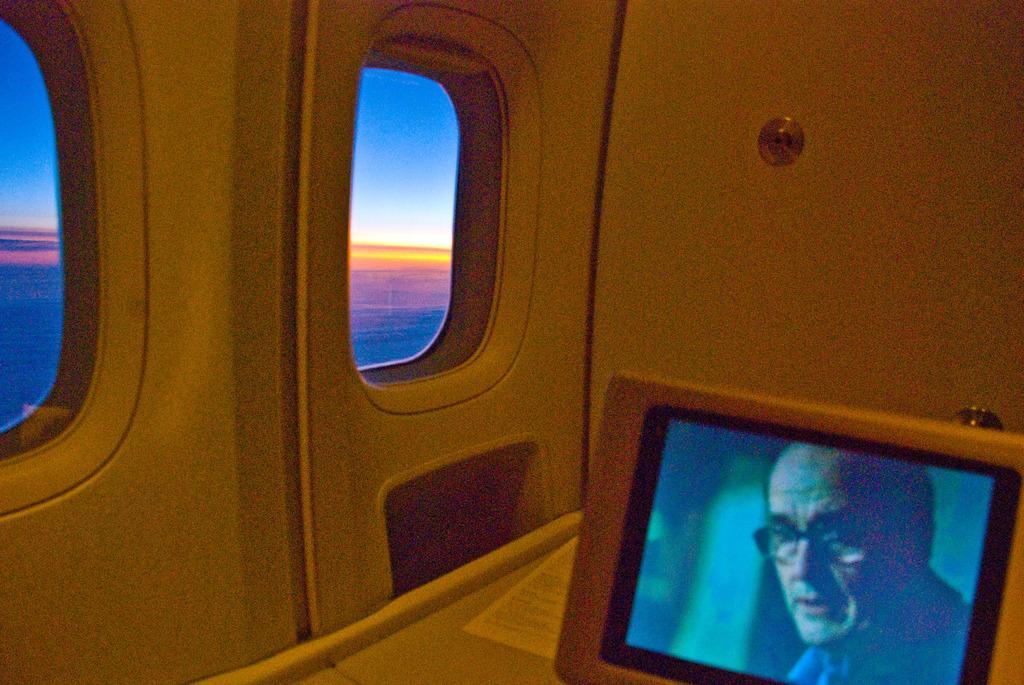In one or two sentences, can you explain what this image depicts? In this image there is an inside view of an airplane, there is the sky, there is a screen towards the bottom of the image, there is a man visible in the screen, there is a paper, there is text on the paper, there are windows. 